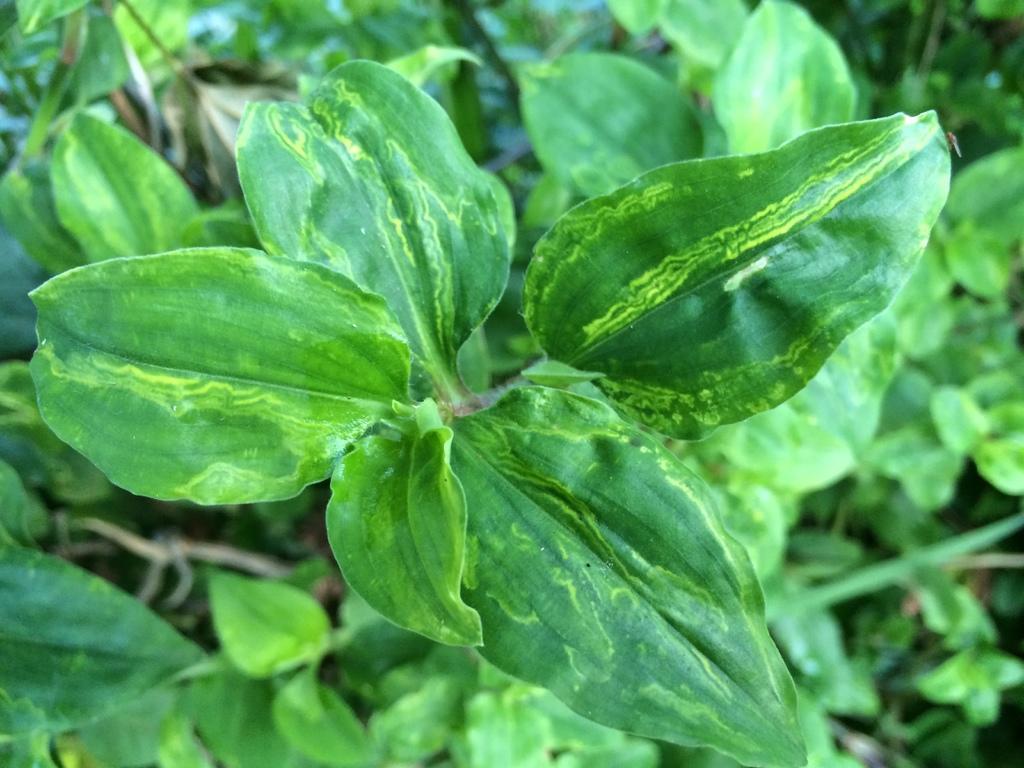How would you summarize this image in a sentence or two? In this image there are few plants. 